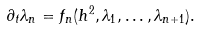<formula> <loc_0><loc_0><loc_500><loc_500>\partial _ { t } \lambda _ { n } = f _ { n } ( h ^ { 2 } , \lambda _ { 1 } , \dots , \lambda _ { n + 1 } ) .</formula> 